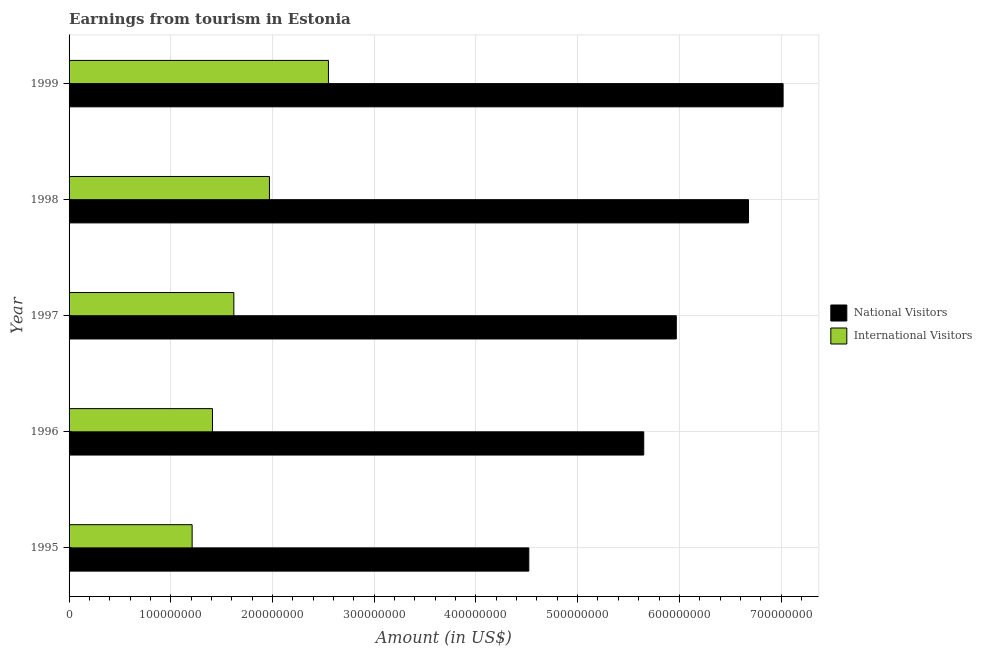How many groups of bars are there?
Your answer should be compact. 5. Are the number of bars per tick equal to the number of legend labels?
Keep it short and to the point. Yes. How many bars are there on the 5th tick from the top?
Your answer should be compact. 2. How many bars are there on the 5th tick from the bottom?
Your response must be concise. 2. In how many cases, is the number of bars for a given year not equal to the number of legend labels?
Ensure brevity in your answer.  0. What is the amount earned from international visitors in 1996?
Your response must be concise. 1.41e+08. Across all years, what is the maximum amount earned from international visitors?
Your answer should be compact. 2.55e+08. Across all years, what is the minimum amount earned from international visitors?
Offer a terse response. 1.21e+08. In which year was the amount earned from international visitors maximum?
Provide a succinct answer. 1999. What is the total amount earned from national visitors in the graph?
Make the answer very short. 2.98e+09. What is the difference between the amount earned from national visitors in 1996 and that in 1999?
Provide a short and direct response. -1.37e+08. What is the difference between the amount earned from international visitors in 1999 and the amount earned from national visitors in 1998?
Make the answer very short. -4.13e+08. What is the average amount earned from international visitors per year?
Keep it short and to the point. 1.75e+08. In the year 1997, what is the difference between the amount earned from national visitors and amount earned from international visitors?
Offer a terse response. 4.35e+08. What is the ratio of the amount earned from national visitors in 1996 to that in 1998?
Ensure brevity in your answer.  0.85. Is the amount earned from national visitors in 1997 less than that in 1999?
Your response must be concise. Yes. What is the difference between the highest and the second highest amount earned from international visitors?
Your response must be concise. 5.80e+07. What is the difference between the highest and the lowest amount earned from national visitors?
Provide a succinct answer. 2.50e+08. In how many years, is the amount earned from national visitors greater than the average amount earned from national visitors taken over all years?
Keep it short and to the point. 3. Is the sum of the amount earned from international visitors in 1997 and 1998 greater than the maximum amount earned from national visitors across all years?
Your response must be concise. No. What does the 1st bar from the top in 1997 represents?
Ensure brevity in your answer.  International Visitors. What does the 2nd bar from the bottom in 1997 represents?
Keep it short and to the point. International Visitors. How many bars are there?
Give a very brief answer. 10. Are the values on the major ticks of X-axis written in scientific E-notation?
Offer a terse response. No. Does the graph contain grids?
Provide a short and direct response. Yes. Where does the legend appear in the graph?
Make the answer very short. Center right. How are the legend labels stacked?
Provide a succinct answer. Vertical. What is the title of the graph?
Make the answer very short. Earnings from tourism in Estonia. Does "Commercial service imports" appear as one of the legend labels in the graph?
Your response must be concise. No. What is the Amount (in US$) of National Visitors in 1995?
Offer a very short reply. 4.52e+08. What is the Amount (in US$) of International Visitors in 1995?
Ensure brevity in your answer.  1.21e+08. What is the Amount (in US$) of National Visitors in 1996?
Provide a succinct answer. 5.65e+08. What is the Amount (in US$) of International Visitors in 1996?
Your answer should be compact. 1.41e+08. What is the Amount (in US$) of National Visitors in 1997?
Keep it short and to the point. 5.97e+08. What is the Amount (in US$) of International Visitors in 1997?
Give a very brief answer. 1.62e+08. What is the Amount (in US$) in National Visitors in 1998?
Provide a short and direct response. 6.68e+08. What is the Amount (in US$) of International Visitors in 1998?
Provide a short and direct response. 1.97e+08. What is the Amount (in US$) in National Visitors in 1999?
Ensure brevity in your answer.  7.02e+08. What is the Amount (in US$) in International Visitors in 1999?
Your answer should be very brief. 2.55e+08. Across all years, what is the maximum Amount (in US$) of National Visitors?
Offer a terse response. 7.02e+08. Across all years, what is the maximum Amount (in US$) of International Visitors?
Provide a short and direct response. 2.55e+08. Across all years, what is the minimum Amount (in US$) in National Visitors?
Give a very brief answer. 4.52e+08. Across all years, what is the minimum Amount (in US$) of International Visitors?
Offer a very short reply. 1.21e+08. What is the total Amount (in US$) of National Visitors in the graph?
Your answer should be compact. 2.98e+09. What is the total Amount (in US$) in International Visitors in the graph?
Give a very brief answer. 8.76e+08. What is the difference between the Amount (in US$) of National Visitors in 1995 and that in 1996?
Ensure brevity in your answer.  -1.13e+08. What is the difference between the Amount (in US$) in International Visitors in 1995 and that in 1996?
Your answer should be very brief. -2.00e+07. What is the difference between the Amount (in US$) in National Visitors in 1995 and that in 1997?
Your response must be concise. -1.45e+08. What is the difference between the Amount (in US$) of International Visitors in 1995 and that in 1997?
Your response must be concise. -4.10e+07. What is the difference between the Amount (in US$) of National Visitors in 1995 and that in 1998?
Your response must be concise. -2.16e+08. What is the difference between the Amount (in US$) of International Visitors in 1995 and that in 1998?
Give a very brief answer. -7.60e+07. What is the difference between the Amount (in US$) of National Visitors in 1995 and that in 1999?
Provide a short and direct response. -2.50e+08. What is the difference between the Amount (in US$) of International Visitors in 1995 and that in 1999?
Ensure brevity in your answer.  -1.34e+08. What is the difference between the Amount (in US$) in National Visitors in 1996 and that in 1997?
Offer a terse response. -3.20e+07. What is the difference between the Amount (in US$) in International Visitors in 1996 and that in 1997?
Your answer should be very brief. -2.10e+07. What is the difference between the Amount (in US$) of National Visitors in 1996 and that in 1998?
Offer a terse response. -1.03e+08. What is the difference between the Amount (in US$) in International Visitors in 1996 and that in 1998?
Your answer should be very brief. -5.60e+07. What is the difference between the Amount (in US$) in National Visitors in 1996 and that in 1999?
Provide a succinct answer. -1.37e+08. What is the difference between the Amount (in US$) in International Visitors in 1996 and that in 1999?
Your response must be concise. -1.14e+08. What is the difference between the Amount (in US$) of National Visitors in 1997 and that in 1998?
Your answer should be very brief. -7.10e+07. What is the difference between the Amount (in US$) of International Visitors in 1997 and that in 1998?
Ensure brevity in your answer.  -3.50e+07. What is the difference between the Amount (in US$) in National Visitors in 1997 and that in 1999?
Provide a succinct answer. -1.05e+08. What is the difference between the Amount (in US$) of International Visitors in 1997 and that in 1999?
Provide a succinct answer. -9.30e+07. What is the difference between the Amount (in US$) of National Visitors in 1998 and that in 1999?
Your response must be concise. -3.40e+07. What is the difference between the Amount (in US$) in International Visitors in 1998 and that in 1999?
Your answer should be very brief. -5.80e+07. What is the difference between the Amount (in US$) of National Visitors in 1995 and the Amount (in US$) of International Visitors in 1996?
Keep it short and to the point. 3.11e+08. What is the difference between the Amount (in US$) of National Visitors in 1995 and the Amount (in US$) of International Visitors in 1997?
Offer a very short reply. 2.90e+08. What is the difference between the Amount (in US$) in National Visitors in 1995 and the Amount (in US$) in International Visitors in 1998?
Provide a short and direct response. 2.55e+08. What is the difference between the Amount (in US$) of National Visitors in 1995 and the Amount (in US$) of International Visitors in 1999?
Provide a short and direct response. 1.97e+08. What is the difference between the Amount (in US$) of National Visitors in 1996 and the Amount (in US$) of International Visitors in 1997?
Your answer should be compact. 4.03e+08. What is the difference between the Amount (in US$) of National Visitors in 1996 and the Amount (in US$) of International Visitors in 1998?
Make the answer very short. 3.68e+08. What is the difference between the Amount (in US$) of National Visitors in 1996 and the Amount (in US$) of International Visitors in 1999?
Keep it short and to the point. 3.10e+08. What is the difference between the Amount (in US$) of National Visitors in 1997 and the Amount (in US$) of International Visitors in 1998?
Your answer should be compact. 4.00e+08. What is the difference between the Amount (in US$) in National Visitors in 1997 and the Amount (in US$) in International Visitors in 1999?
Your response must be concise. 3.42e+08. What is the difference between the Amount (in US$) in National Visitors in 1998 and the Amount (in US$) in International Visitors in 1999?
Ensure brevity in your answer.  4.13e+08. What is the average Amount (in US$) in National Visitors per year?
Give a very brief answer. 5.97e+08. What is the average Amount (in US$) in International Visitors per year?
Give a very brief answer. 1.75e+08. In the year 1995, what is the difference between the Amount (in US$) of National Visitors and Amount (in US$) of International Visitors?
Your answer should be compact. 3.31e+08. In the year 1996, what is the difference between the Amount (in US$) in National Visitors and Amount (in US$) in International Visitors?
Provide a succinct answer. 4.24e+08. In the year 1997, what is the difference between the Amount (in US$) of National Visitors and Amount (in US$) of International Visitors?
Ensure brevity in your answer.  4.35e+08. In the year 1998, what is the difference between the Amount (in US$) in National Visitors and Amount (in US$) in International Visitors?
Your answer should be very brief. 4.71e+08. In the year 1999, what is the difference between the Amount (in US$) of National Visitors and Amount (in US$) of International Visitors?
Offer a very short reply. 4.47e+08. What is the ratio of the Amount (in US$) of National Visitors in 1995 to that in 1996?
Give a very brief answer. 0.8. What is the ratio of the Amount (in US$) of International Visitors in 1995 to that in 1996?
Make the answer very short. 0.86. What is the ratio of the Amount (in US$) of National Visitors in 1995 to that in 1997?
Your answer should be very brief. 0.76. What is the ratio of the Amount (in US$) of International Visitors in 1995 to that in 1997?
Give a very brief answer. 0.75. What is the ratio of the Amount (in US$) of National Visitors in 1995 to that in 1998?
Your answer should be compact. 0.68. What is the ratio of the Amount (in US$) of International Visitors in 1995 to that in 1998?
Provide a succinct answer. 0.61. What is the ratio of the Amount (in US$) in National Visitors in 1995 to that in 1999?
Offer a very short reply. 0.64. What is the ratio of the Amount (in US$) of International Visitors in 1995 to that in 1999?
Your answer should be compact. 0.47. What is the ratio of the Amount (in US$) of National Visitors in 1996 to that in 1997?
Your answer should be very brief. 0.95. What is the ratio of the Amount (in US$) in International Visitors in 1996 to that in 1997?
Your response must be concise. 0.87. What is the ratio of the Amount (in US$) of National Visitors in 1996 to that in 1998?
Your answer should be very brief. 0.85. What is the ratio of the Amount (in US$) of International Visitors in 1996 to that in 1998?
Give a very brief answer. 0.72. What is the ratio of the Amount (in US$) in National Visitors in 1996 to that in 1999?
Your answer should be compact. 0.8. What is the ratio of the Amount (in US$) in International Visitors in 1996 to that in 1999?
Your answer should be compact. 0.55. What is the ratio of the Amount (in US$) of National Visitors in 1997 to that in 1998?
Your answer should be compact. 0.89. What is the ratio of the Amount (in US$) of International Visitors in 1997 to that in 1998?
Provide a short and direct response. 0.82. What is the ratio of the Amount (in US$) in National Visitors in 1997 to that in 1999?
Your answer should be very brief. 0.85. What is the ratio of the Amount (in US$) in International Visitors in 1997 to that in 1999?
Your answer should be compact. 0.64. What is the ratio of the Amount (in US$) of National Visitors in 1998 to that in 1999?
Provide a short and direct response. 0.95. What is the ratio of the Amount (in US$) in International Visitors in 1998 to that in 1999?
Ensure brevity in your answer.  0.77. What is the difference between the highest and the second highest Amount (in US$) in National Visitors?
Your response must be concise. 3.40e+07. What is the difference between the highest and the second highest Amount (in US$) of International Visitors?
Offer a very short reply. 5.80e+07. What is the difference between the highest and the lowest Amount (in US$) in National Visitors?
Offer a terse response. 2.50e+08. What is the difference between the highest and the lowest Amount (in US$) in International Visitors?
Your answer should be very brief. 1.34e+08. 